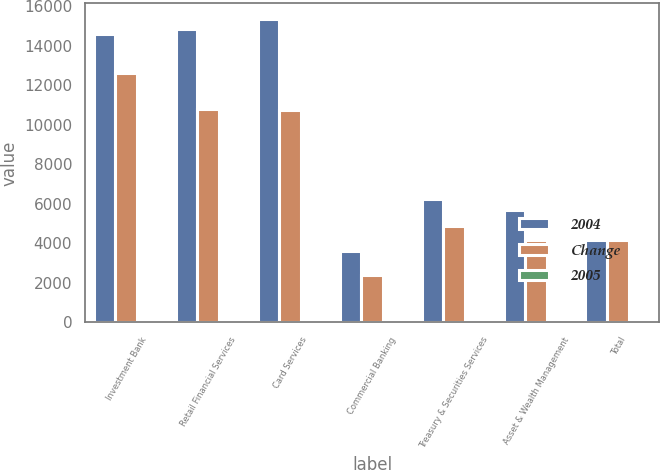<chart> <loc_0><loc_0><loc_500><loc_500><stacked_bar_chart><ecel><fcel>Investment Bank<fcel>Retail Financial Services<fcel>Card Services<fcel>Commercial Banking<fcel>Treasury & Securities Services<fcel>Asset & Wealth Management<fcel>Total<nl><fcel>2004<fcel>14578<fcel>14830<fcel>15366<fcel>3596<fcel>6241<fcel>5664<fcel>4179<nl><fcel>Change<fcel>12605<fcel>10791<fcel>10745<fcel>2374<fcel>4857<fcel>4179<fcel>4179<nl><fcel>2005<fcel>16<fcel>37<fcel>43<fcel>51<fcel>28<fcel>36<fcel>27<nl></chart> 